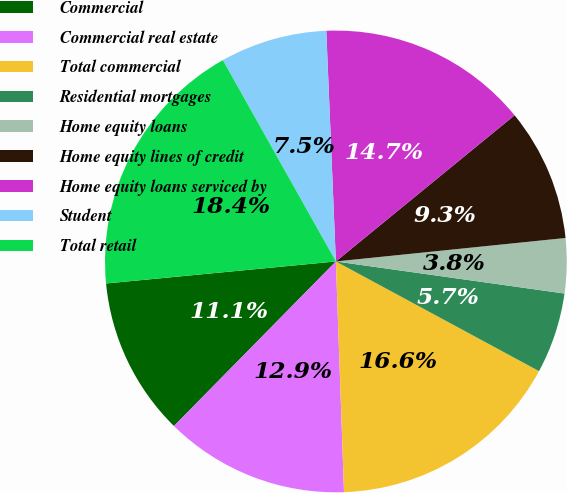Convert chart to OTSL. <chart><loc_0><loc_0><loc_500><loc_500><pie_chart><fcel>Commercial<fcel>Commercial real estate<fcel>Total commercial<fcel>Residential mortgages<fcel>Home equity loans<fcel>Home equity lines of credit<fcel>Home equity loans serviced by<fcel>Student<fcel>Total retail<nl><fcel>11.11%<fcel>12.93%<fcel>16.56%<fcel>5.66%<fcel>3.84%<fcel>9.29%<fcel>14.75%<fcel>7.48%<fcel>18.38%<nl></chart> 